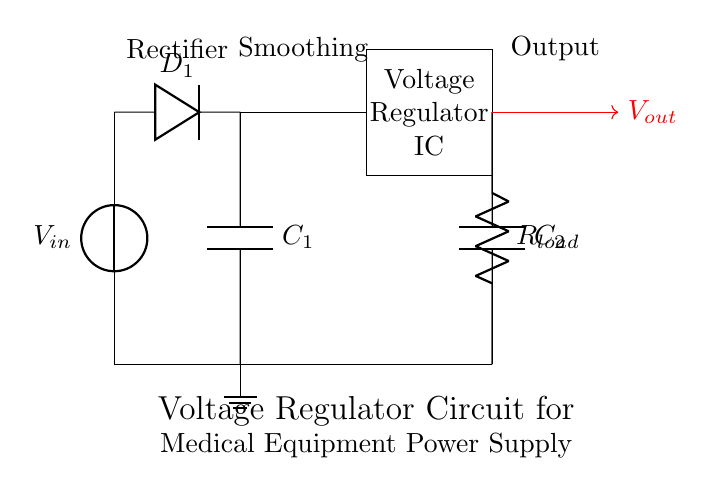What type of component is D1? D1 is a diode, which is used for allowing current to flow in one direction only. This component is specifically labeled as a rectifier diode in the circuit diagram.
Answer: diode What is the role of C1? C1 is a smoothing capacitor, which is used to filter the output of the rectifier, reducing voltage fluctuations and providing a smoother voltage output. This is indicated by its label in the circuit.
Answer: smoothing capacitor How many capacitors are present in the circuit? There are two capacitors in the circuit: C1 and C2. Their presence is denoted by the labels next to the components in the diagram.
Answer: two What is the function of the voltage regulator IC? The voltage regulator IC provides a constant output voltage, despite variations in input voltage or load conditions. Its specific role is to stabilize the power supply for the connected load.
Answer: constant output voltage What is the output voltage labeled as? The output voltage is labeled as Vout, which is the voltage delivered to the load after regulation and filtering. This is shown by the red arrow in the circuit diagram pointing towards the load.
Answer: Vout What would happen if C2 was removed? If C2 was removed, the output would likely have higher ripple and be less stable, as C2 helps to filter and maintain a steady voltage across the load. Without it, the load might not receive a proper power supply.
Answer: higher ripple What is the load in this circuit? The load in this circuit is represented by Rload, which is a resistor indicating where the power is being delivered. This component is specifically labeled in the circuit design.
Answer: Rload 